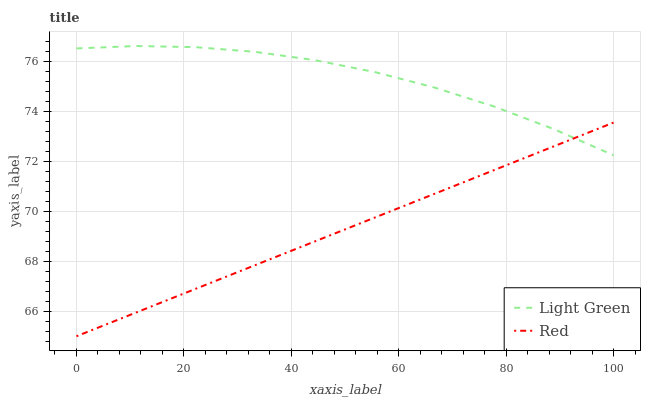Does Red have the minimum area under the curve?
Answer yes or no. Yes. Does Light Green have the maximum area under the curve?
Answer yes or no. Yes. Does Light Green have the minimum area under the curve?
Answer yes or no. No. Is Red the smoothest?
Answer yes or no. Yes. Is Light Green the roughest?
Answer yes or no. Yes. Is Light Green the smoothest?
Answer yes or no. No. Does Red have the lowest value?
Answer yes or no. Yes. Does Light Green have the lowest value?
Answer yes or no. No. Does Light Green have the highest value?
Answer yes or no. Yes. Does Red intersect Light Green?
Answer yes or no. Yes. Is Red less than Light Green?
Answer yes or no. No. Is Red greater than Light Green?
Answer yes or no. No. 